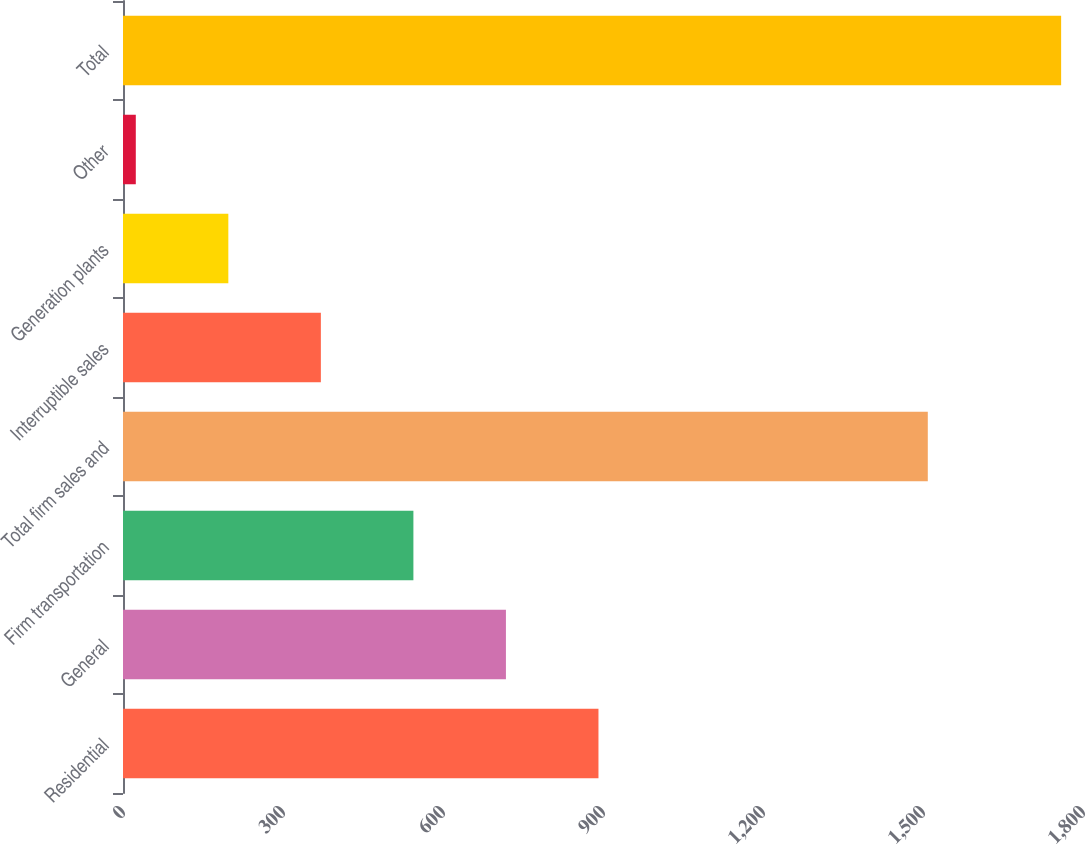Convert chart to OTSL. <chart><loc_0><loc_0><loc_500><loc_500><bar_chart><fcel>Residential<fcel>General<fcel>Firm transportation<fcel>Total firm sales and<fcel>Interruptible sales<fcel>Generation plants<fcel>Other<fcel>Total<nl><fcel>891.5<fcel>718<fcel>544.5<fcel>1509<fcel>371<fcel>197.5<fcel>24<fcel>1759<nl></chart> 